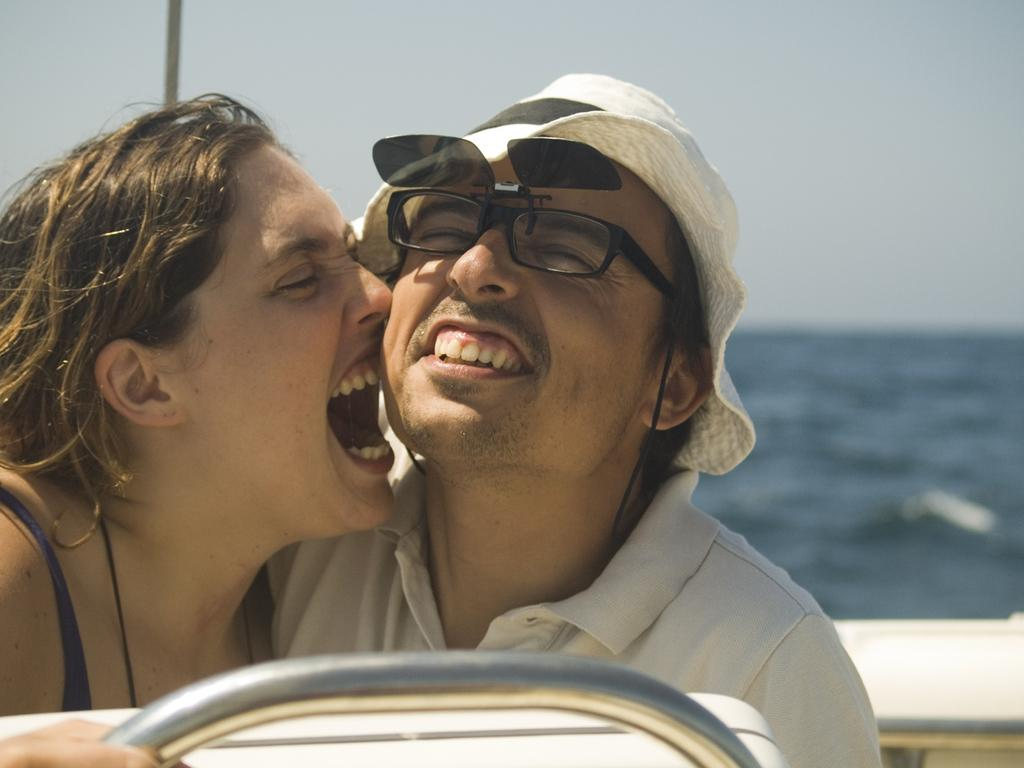Who is present in the image? There is a man and a woman in the image. What are the man and the woman doing in the image? Both the man and the woman are sitting in a boat. What can be seen in the background of the image? There is water visible in the background of the image. What is visible at the top of the image? The sky is visible at the top of the image. What type of flesh can be seen in the image? There is no flesh visible in the image; it features a man and a woman sitting in a boat. What is the woman's desire in the image? There is no indication of the woman's desires in the image, as it only shows her sitting in a boat with a man. 